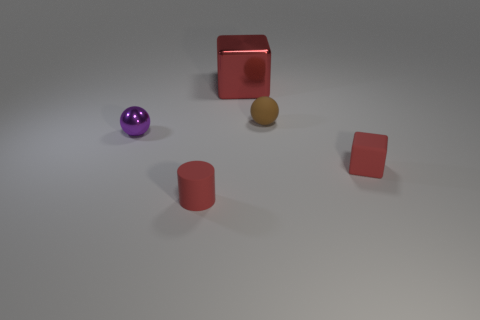Add 3 small red matte things. How many objects exist? 8 Subtract all cylinders. How many objects are left? 4 Subtract 1 blocks. How many blocks are left? 1 Subtract all brown balls. How many balls are left? 1 Subtract all blue cubes. Subtract all yellow balls. How many cubes are left? 2 Subtract all tiny cyan spheres. Subtract all tiny red rubber cylinders. How many objects are left? 4 Add 2 matte things. How many matte things are left? 5 Add 1 green metal balls. How many green metal balls exist? 1 Subtract 1 red cylinders. How many objects are left? 4 